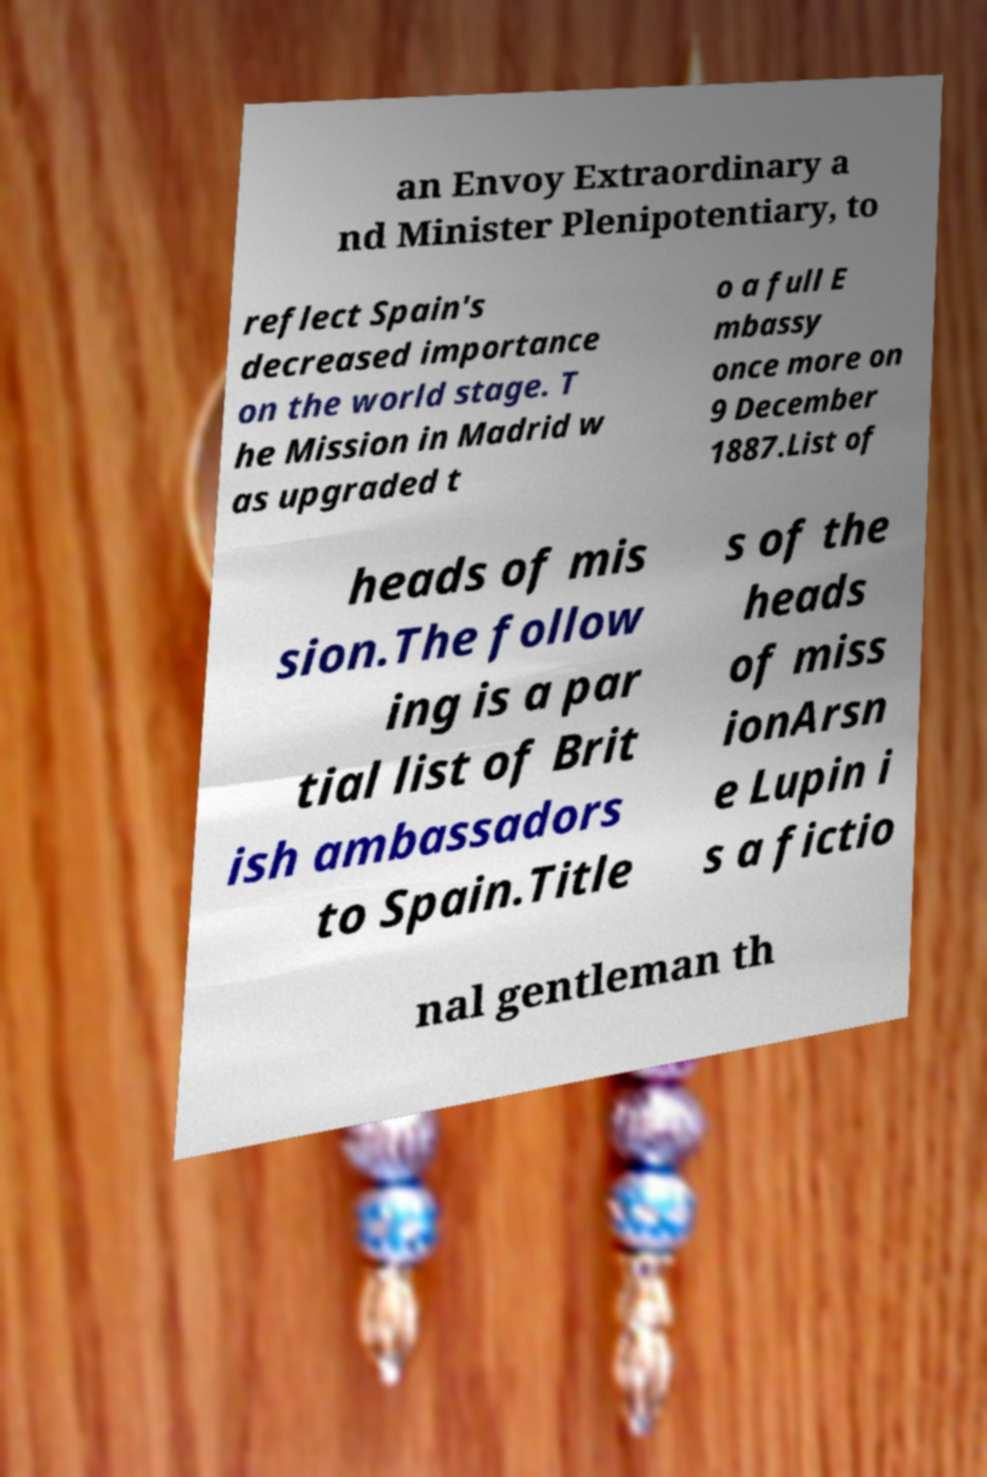Please identify and transcribe the text found in this image. an Envoy Extraordinary a nd Minister Plenipotentiary, to reflect Spain's decreased importance on the world stage. T he Mission in Madrid w as upgraded t o a full E mbassy once more on 9 December 1887.List of heads of mis sion.The follow ing is a par tial list of Brit ish ambassadors to Spain.Title s of the heads of miss ionArsn e Lupin i s a fictio nal gentleman th 